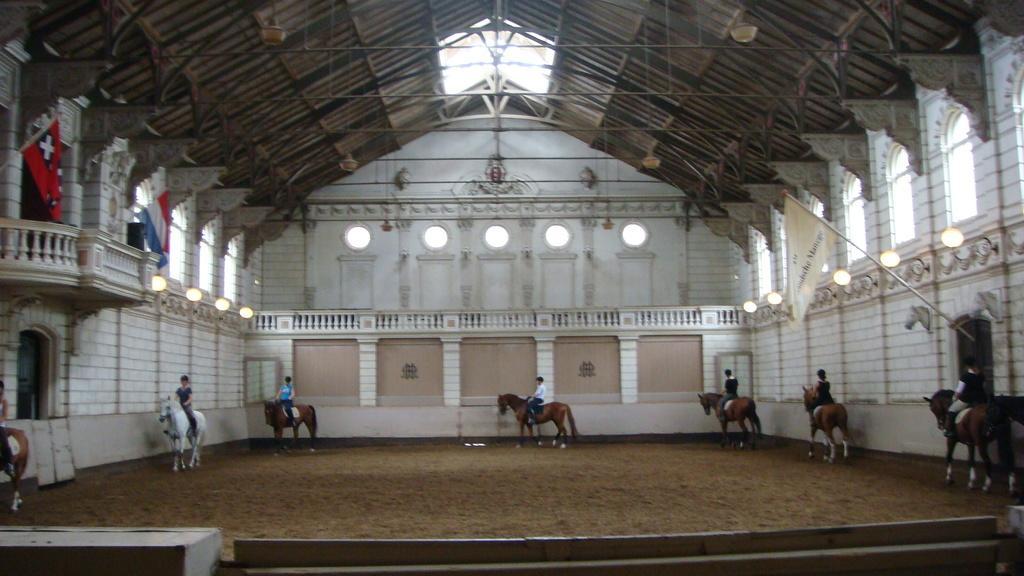In one or two sentences, can you explain what this image depicts? This picture is clicked under the tent and we can see the group of persons riding horses. In the background we can see the wall, windows, flag, lights and at the top we can see the roof, metal rods, flags, guardrail and many other objects. 